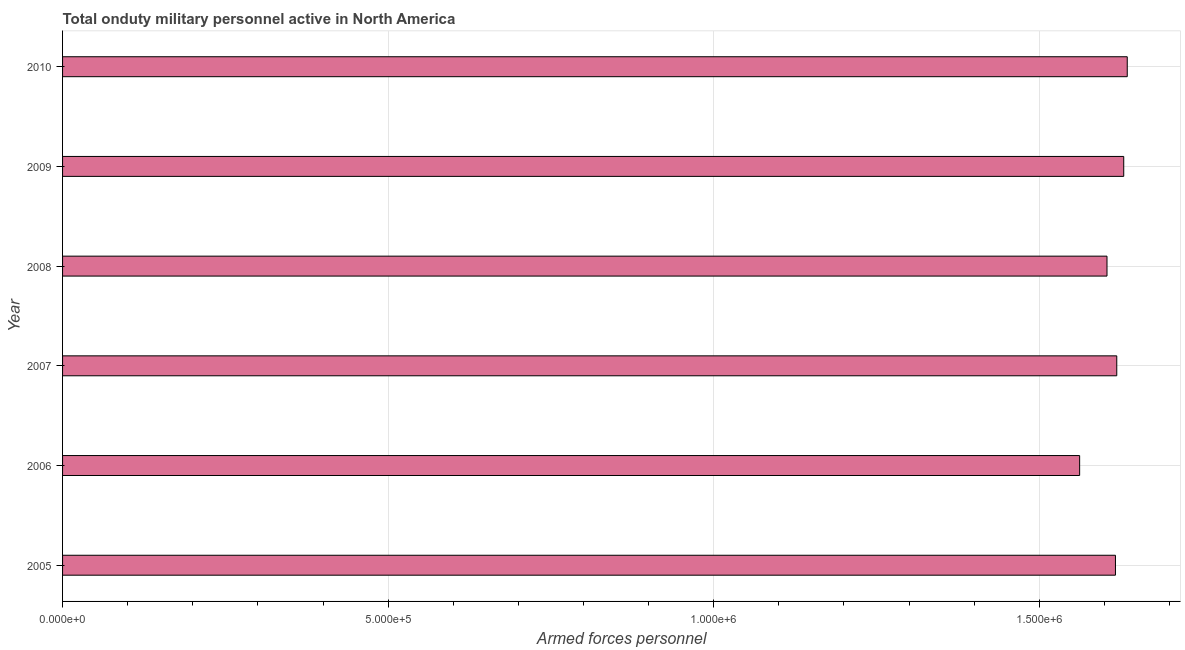Does the graph contain grids?
Offer a very short reply. Yes. What is the title of the graph?
Offer a very short reply. Total onduty military personnel active in North America. What is the label or title of the X-axis?
Make the answer very short. Armed forces personnel. What is the number of armed forces personnel in 2006?
Your response must be concise. 1.56e+06. Across all years, what is the maximum number of armed forces personnel?
Offer a terse response. 1.64e+06. Across all years, what is the minimum number of armed forces personnel?
Your answer should be compact. 1.56e+06. What is the sum of the number of armed forces personnel?
Your answer should be compact. 9.67e+06. What is the difference between the number of armed forces personnel in 2008 and 2010?
Make the answer very short. -3.11e+04. What is the average number of armed forces personnel per year?
Make the answer very short. 1.61e+06. What is the median number of armed forces personnel?
Provide a succinct answer. 1.62e+06. What is the difference between the highest and the second highest number of armed forces personnel?
Make the answer very short. 5399. What is the difference between the highest and the lowest number of armed forces personnel?
Your answer should be compact. 7.31e+04. How many bars are there?
Provide a succinct answer. 6. What is the difference between two consecutive major ticks on the X-axis?
Your answer should be very brief. 5.00e+05. Are the values on the major ticks of X-axis written in scientific E-notation?
Offer a terse response. Yes. What is the Armed forces personnel in 2005?
Provide a short and direct response. 1.62e+06. What is the Armed forces personnel of 2006?
Your answer should be compact. 1.56e+06. What is the Armed forces personnel in 2007?
Provide a succinct answer. 1.62e+06. What is the Armed forces personnel of 2008?
Your answer should be very brief. 1.60e+06. What is the Armed forces personnel in 2009?
Provide a succinct answer. 1.63e+06. What is the Armed forces personnel of 2010?
Make the answer very short. 1.64e+06. What is the difference between the Armed forces personnel in 2005 and 2006?
Your response must be concise. 5.50e+04. What is the difference between the Armed forces personnel in 2005 and 2007?
Keep it short and to the point. -2000. What is the difference between the Armed forces personnel in 2005 and 2008?
Offer a terse response. 1.30e+04. What is the difference between the Armed forces personnel in 2005 and 2009?
Give a very brief answer. -1.27e+04. What is the difference between the Armed forces personnel in 2005 and 2010?
Provide a short and direct response. -1.81e+04. What is the difference between the Armed forces personnel in 2006 and 2007?
Provide a short and direct response. -5.70e+04. What is the difference between the Armed forces personnel in 2006 and 2008?
Ensure brevity in your answer.  -4.20e+04. What is the difference between the Armed forces personnel in 2006 and 2009?
Keep it short and to the point. -6.77e+04. What is the difference between the Armed forces personnel in 2006 and 2010?
Ensure brevity in your answer.  -7.31e+04. What is the difference between the Armed forces personnel in 2007 and 2008?
Your response must be concise. 1.50e+04. What is the difference between the Armed forces personnel in 2007 and 2009?
Your answer should be compact. -1.07e+04. What is the difference between the Armed forces personnel in 2007 and 2010?
Make the answer very short. -1.61e+04. What is the difference between the Armed forces personnel in 2008 and 2009?
Give a very brief answer. -2.57e+04. What is the difference between the Armed forces personnel in 2008 and 2010?
Provide a short and direct response. -3.11e+04. What is the difference between the Armed forces personnel in 2009 and 2010?
Your response must be concise. -5399. What is the ratio of the Armed forces personnel in 2005 to that in 2006?
Your answer should be very brief. 1.03. What is the ratio of the Armed forces personnel in 2005 to that in 2008?
Offer a very short reply. 1.01. What is the ratio of the Armed forces personnel in 2006 to that in 2007?
Offer a very short reply. 0.96. What is the ratio of the Armed forces personnel in 2006 to that in 2009?
Your answer should be compact. 0.96. What is the ratio of the Armed forces personnel in 2006 to that in 2010?
Provide a succinct answer. 0.95. What is the ratio of the Armed forces personnel in 2008 to that in 2009?
Provide a short and direct response. 0.98. What is the ratio of the Armed forces personnel in 2008 to that in 2010?
Your answer should be very brief. 0.98. 